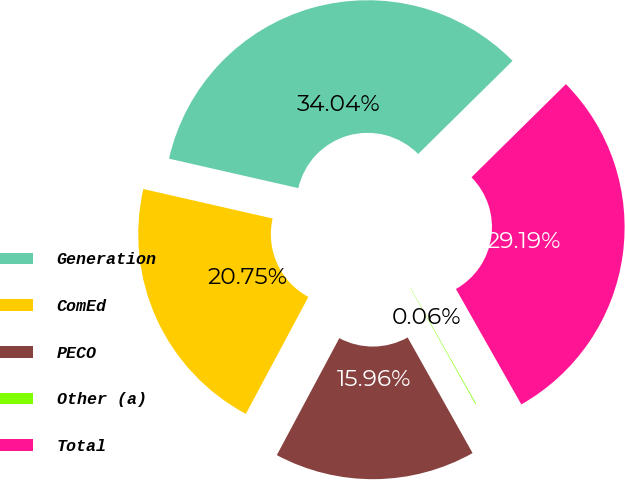Convert chart. <chart><loc_0><loc_0><loc_500><loc_500><pie_chart><fcel>Generation<fcel>ComEd<fcel>PECO<fcel>Other (a)<fcel>Total<nl><fcel>34.04%<fcel>20.75%<fcel>15.96%<fcel>0.06%<fcel>29.19%<nl></chart> 